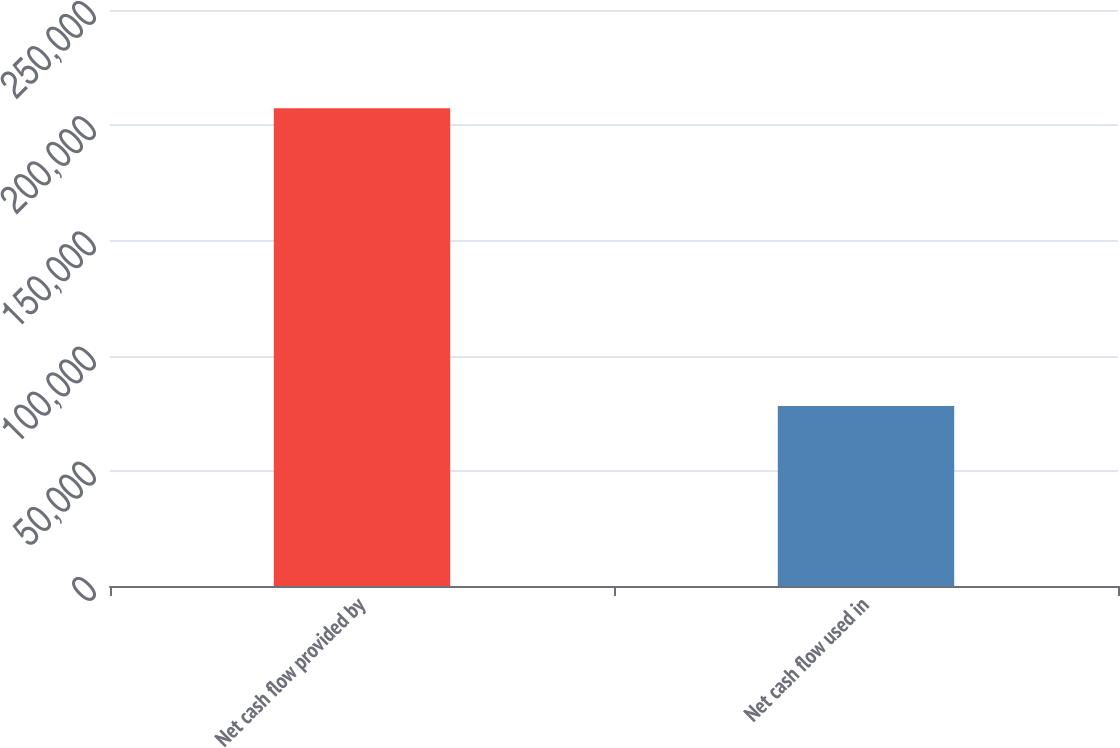Convert chart to OTSL. <chart><loc_0><loc_0><loc_500><loc_500><bar_chart><fcel>Net cash flow provided by<fcel>Net cash flow used in<nl><fcel>207403<fcel>78120<nl></chart> 